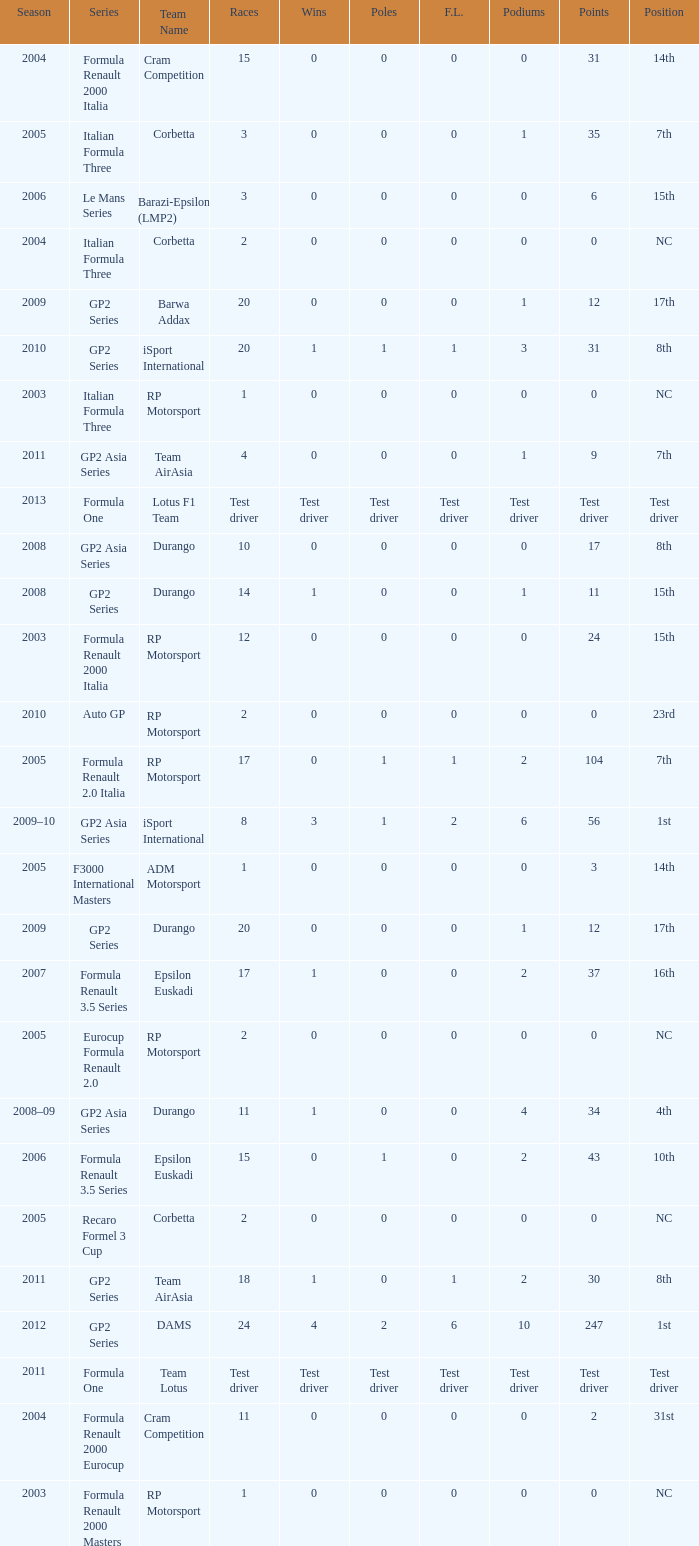What races have gp2 series, 0 F.L. and a 17th position? 20, 20. 